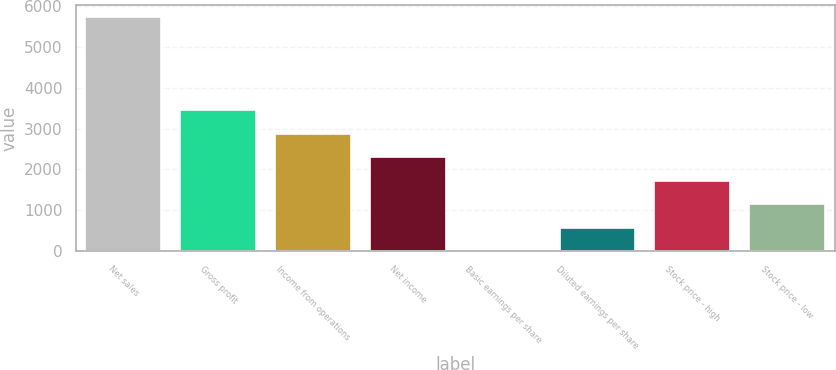Convert chart. <chart><loc_0><loc_0><loc_500><loc_500><bar_chart><fcel>Net sales<fcel>Gross profit<fcel>Income from operations<fcel>Net income<fcel>Basic earnings per share<fcel>Diluted earnings per share<fcel>Stock price - high<fcel>Stock price - low<nl><fcel>5741.7<fcel>3446.79<fcel>2873.07<fcel>2299.35<fcel>4.47<fcel>578.19<fcel>1725.63<fcel>1151.91<nl></chart> 